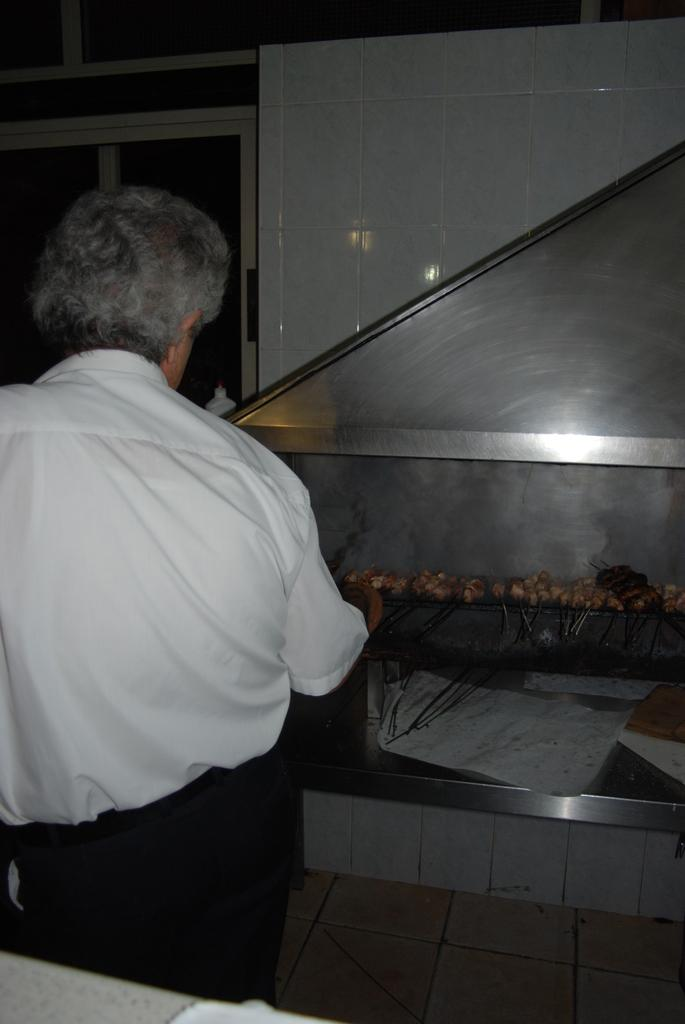What is the man in the image doing? The man is cooking food in the image. Where is the man located in the image? The man is on the left side of the image. What is the man wearing? The man is wearing a dress with white and black colors. What is the man's tendency to use a needle while cooking in the image? There is no mention of a needle in the image, and therefore no information about the man's tendency to use one while cooking. 